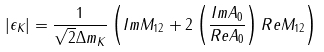Convert formula to latex. <formula><loc_0><loc_0><loc_500><loc_500>| \epsilon _ { K } | = \frac { 1 } { \sqrt { 2 } \Delta m _ { K } } \left ( I m M _ { 1 2 } + 2 \left ( \frac { I m A _ { 0 } } { R e A _ { 0 } } \right ) R e M _ { 1 2 } \right )</formula> 